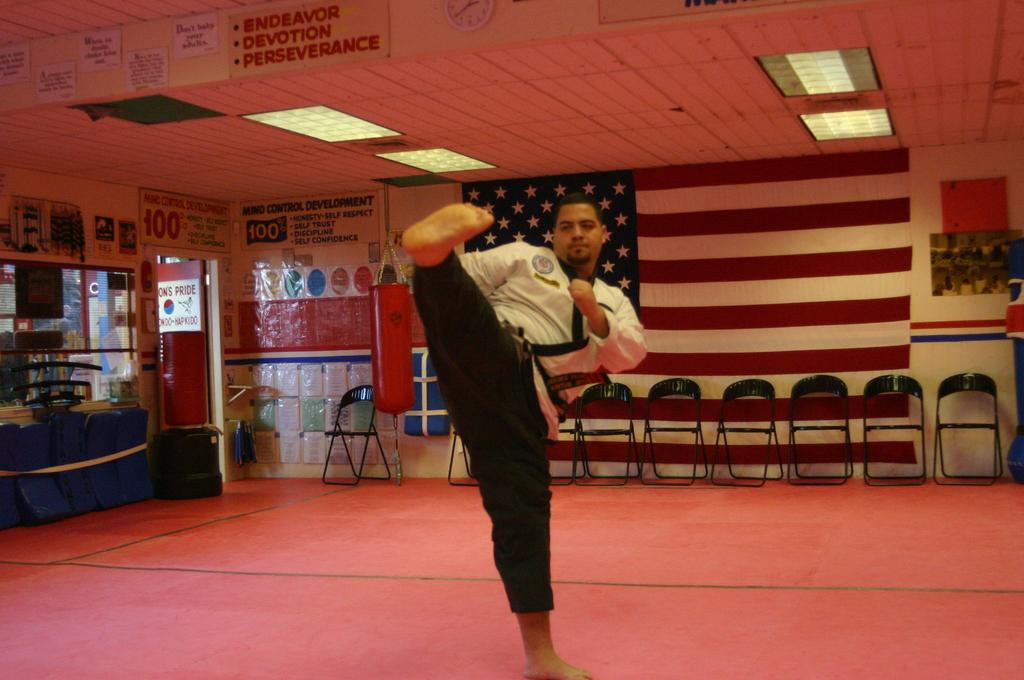<image>
Present a compact description of the photo's key features. The sign hanging from the ceiling at this event says endeavor, devotion, perseverance. 